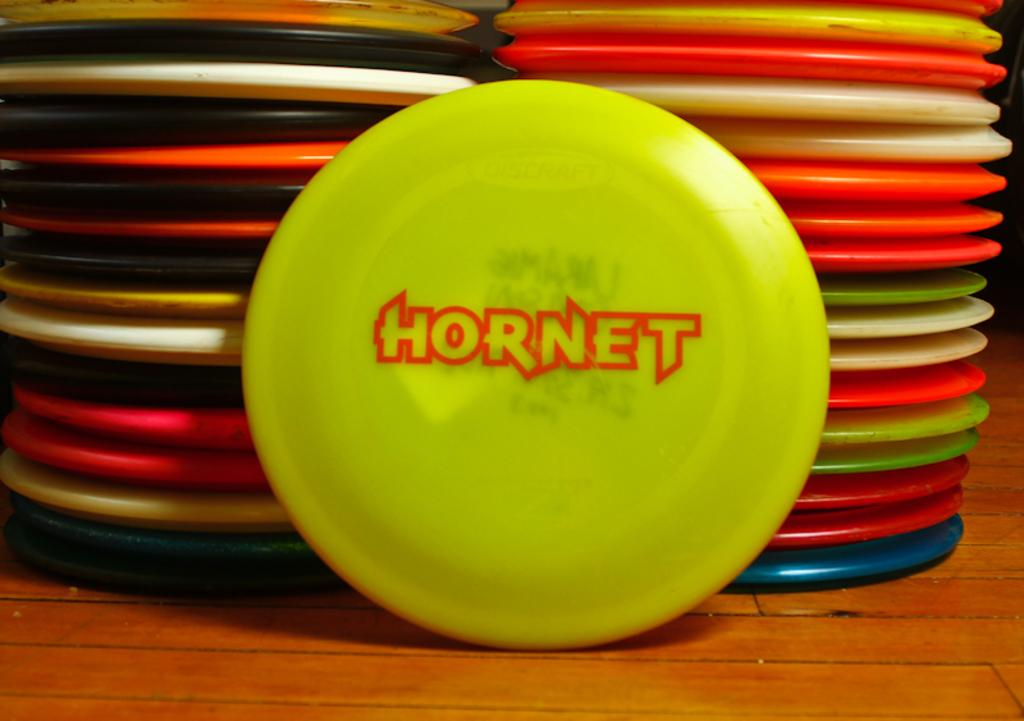What can be observed in the image? There are objects in the image. Can you describe the appearance of the objects? The objects have different colors. Is there any blood visible on the objects in the image? There is no mention of blood in the provided facts, and therefore it cannot be determined if blood is visible in the image. 